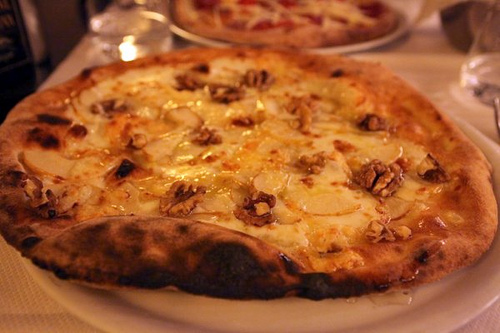<image>
Can you confirm if the pizza is behind the pizza? Yes. From this viewpoint, the pizza is positioned behind the pizza, with the pizza partially or fully occluding the pizza. 